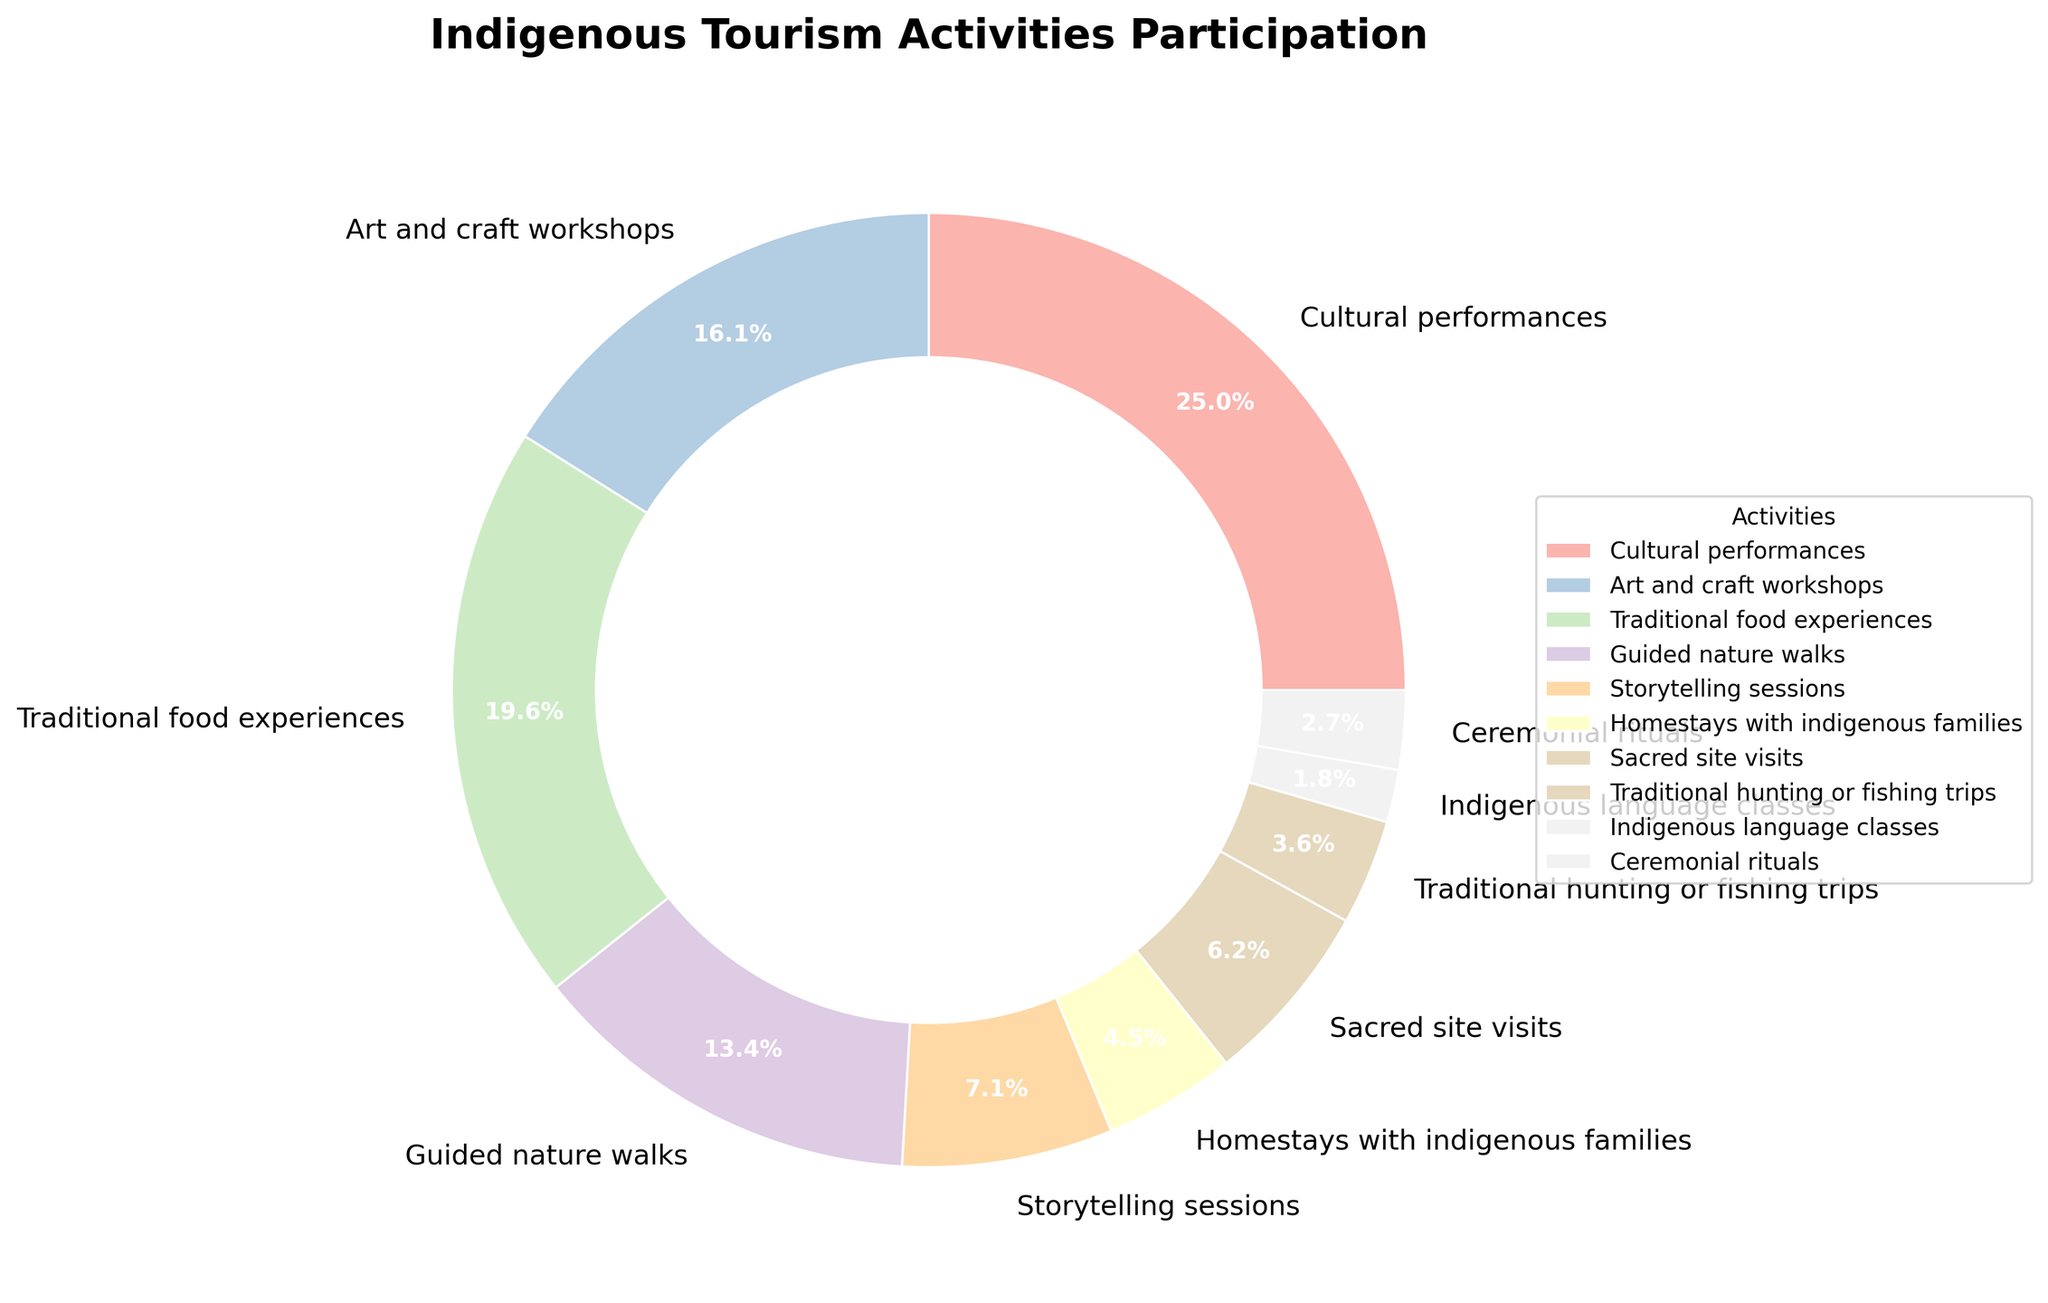What percentage of tourists participate in cultural performances? The pie chart shows the percentage labeled alongside each activity. Locate the segment labeled "Cultural performances" and read the percentage from there.
Answer: 28% Which indigenous tourism activity has the second-highest participation rate? By examining the pie chart, identify the activity with the highest percentage first, then find the second largest. The highest is Cultural performances (28%), followed by Traditional food experiences (22%).
Answer: Traditional food experiences How much more popular are guided nature walks than homestays with indigenous families? Find the segments labeled "Guided nature walks" (15%) and "Homestays with indigenous families" (5%). Subtract the smaller percentage from the larger one: 15% - 5% = 10%.
Answer: 10% What is the total percentage of tourists participating in traditional activities like cultural performances, traditional food experiences, and ceremonial rituals? Sum the percentages of cultural performances (28%), traditional food experiences (22%), and ceremonial rituals (3%): 28% + 22% + 3% = 53%.
Answer: 53% Compare the participation rates of sacred site visits and storytelling sessions. Which one is higher? By how much? Identify the percentages for sacred site visits (7%) and storytelling sessions (8%). Storytelling sessions have a higher participation rate. Difference: 8% - 7% = 1%.
Answer: Storytelling sessions by 1% What is the combined percentage of tourists participating in art and craft workshops and indigenous language classes? Sum the percentages of art and craft workshops (18%) and indigenous language classes (2%): 18% + 2% = 20%.
Answer: 20% Which activity has the lowest participation rate, and what is that rate? Locate the smallest segment in the pie chart. The segment for Indigenous language classes has the smallest percentage, labeled as 2%.
Answer: Indigenous language classes, 2% What is the visual difference in the pie chart between the segments for guided nature walks and traditional hunting or fishing trips? The segment for guided nature walks is larger than the segment for traditional hunting or fishing trips. Guided nature walks (15%) is visually larger compared to traditional hunting or fishing trips (4%).
Answer: Guided nature walks segment is larger Among all activities shown, what percentage of tourists participate in activities that have a participation rate of 10% or lower? Identify activities with 10% or lower: Storytelling sessions (8%), Homestays with indigenous families (5%), Sacred site visits (7%), Traditional hunting or fishing trips (4%), Indigenous language classes (2%), Ceremonial rituals (3%). Sum the percentages: 8% + 5% + 7% + 4% + 2% + 3% = 29%.
Answer: 29% Compare the combined participation rate of traditional food experiences and guided nature walks with cultural performances. Which is higher, and by how much? Calculate the sum for traditional food experiences (22%) and guided nature walks (15%): 22% + 15% = 37%. Compare it with cultural performances (28%). 37% - 28% = 9%. The combined rate is higher by 9%.
Answer: Combined rate by 9% 